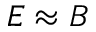Convert formula to latex. <formula><loc_0><loc_0><loc_500><loc_500>E \approx B</formula> 